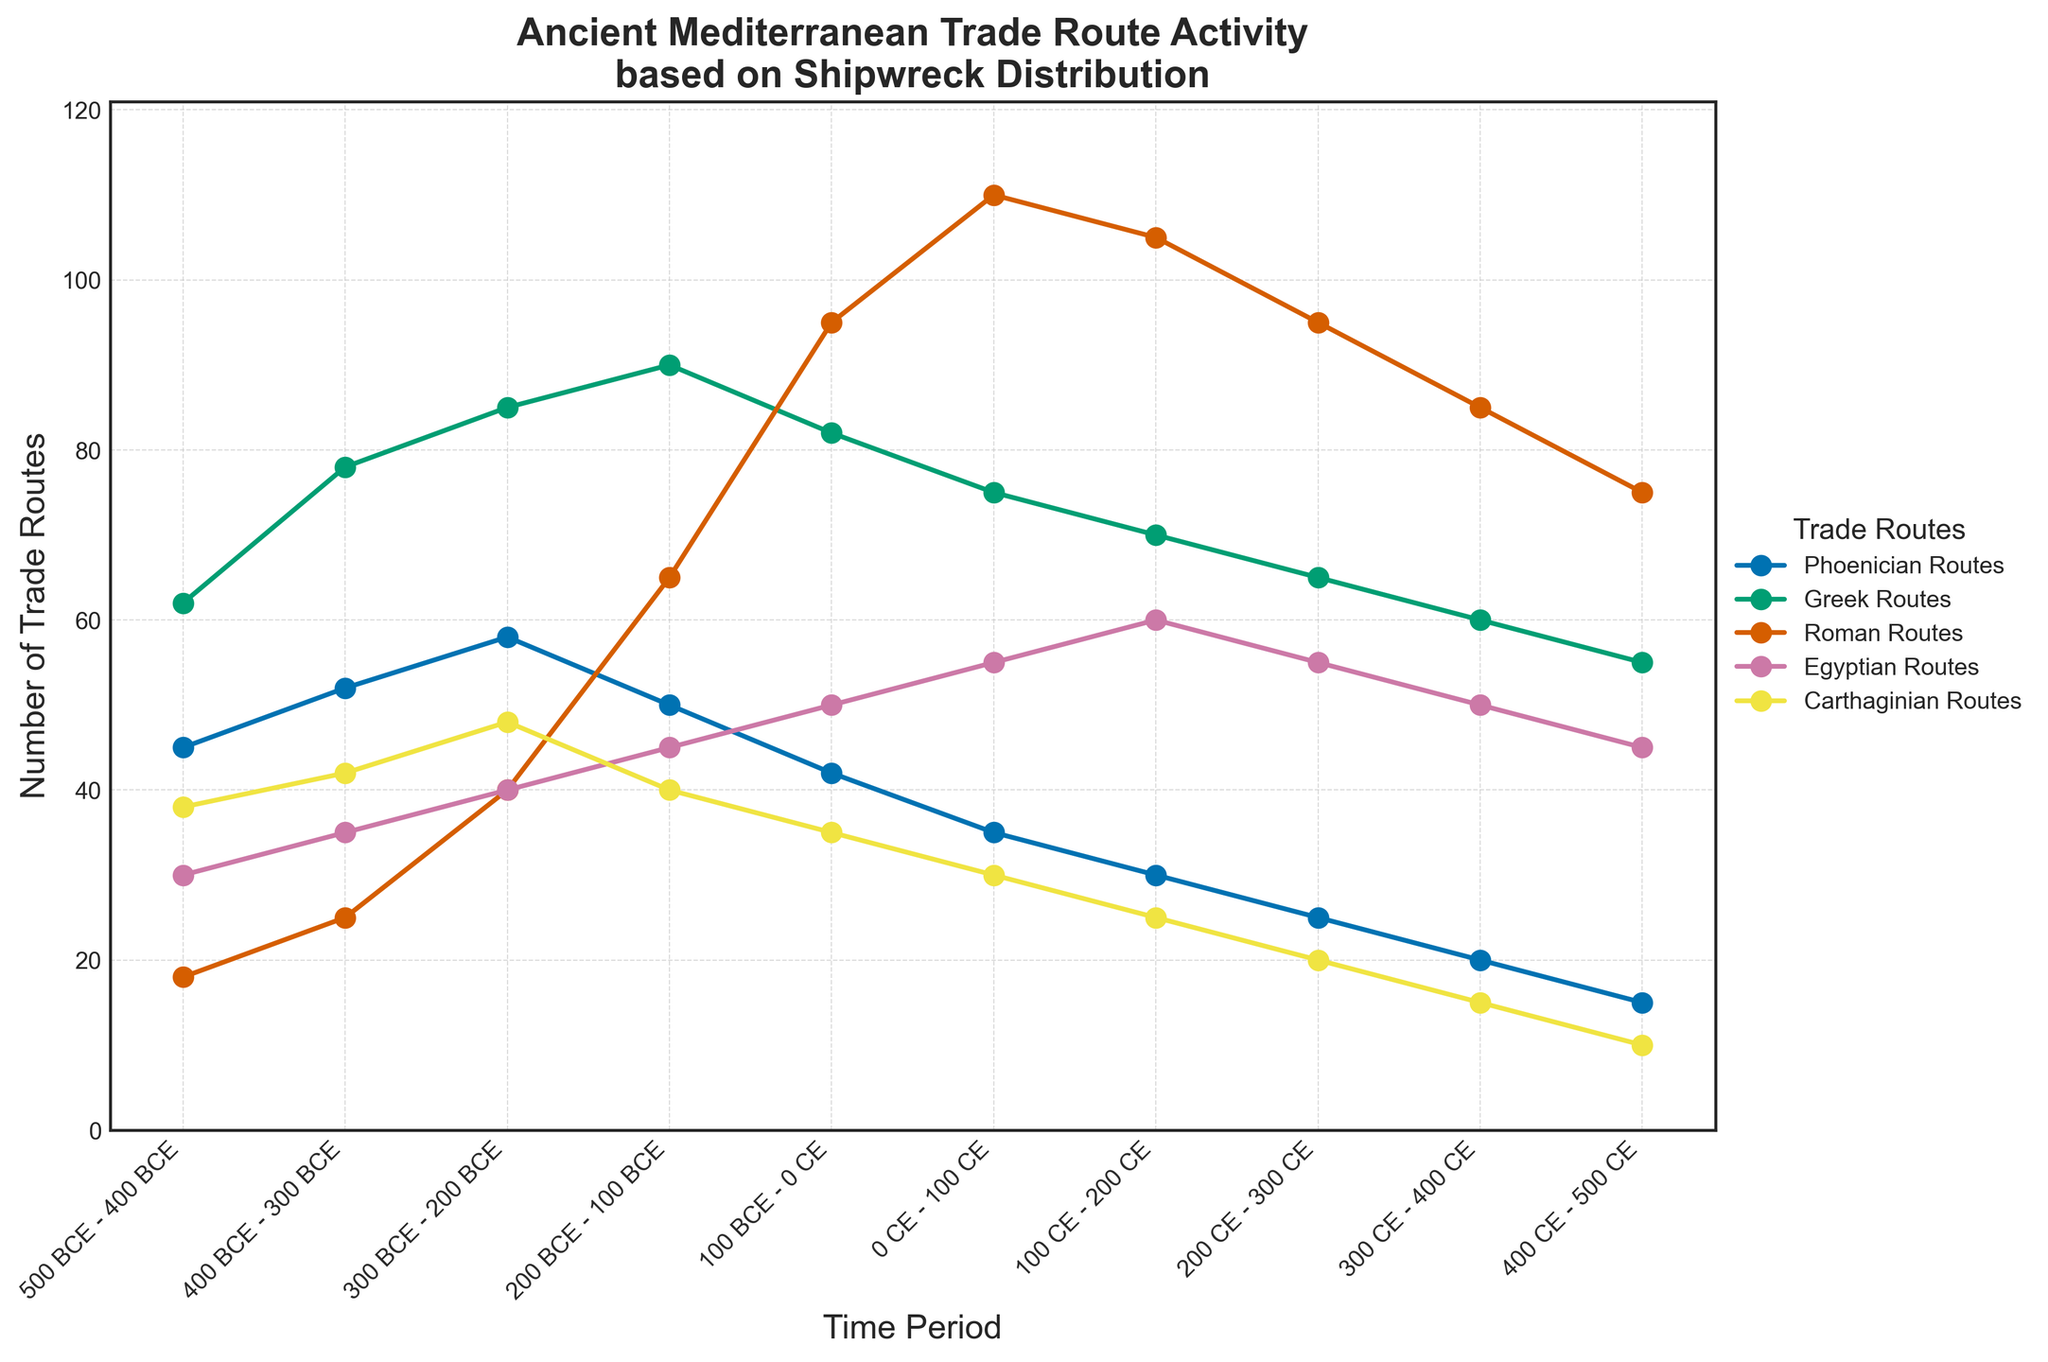What's the approximate difference in the number of Roman Routes between 0 CE - 100 CE and 400 CE - 500 CE? First, identify the number of Roman Routes in 0 CE - 100 CE, which is 110. Then, find the number of Roman Routes in 400 CE - 500 CE, which is 75. Subtract the latter from the former: 110 - 75 = 35
Answer: 35 During which time period did the Phoenician Routes peak? To find when the Phoenician Routes were highest, identify the highest value in the data. The peak value for Phoenician Routes is 58 during the period 300 BCE - 200 BCE.
Answer: 300 BCE - 200 BCE Comparing Egyptian Routes, where do we see the maximum activity and how many routes are recorded? Look at the Egyptian Routes values across all time periods. The maximum activity occurs in the period 100 CE - 200 CE with 60 routes.
Answer: 100 CE - 200 CE, 60 routes What trend do you observe in the number of Carthaginian Routes over time? Assess the numbers of Carthaginian Routes across each time period. The number generally decreases from 38 routes in 500 BCE - 400 BCE to 10 routes in 400 CE - 500 CE.
Answer: Decreasing trend Between which two consecutive time periods did the Greek Routes experience the largest increase? Compare the Greek Routes values between each consecutive time period to spot the largest difference. Notice the jump from 25 in 400 BCE - 300 BCE to 40 in 300 BCE - 200 BCE, an increase of 37 routes.
Answer: 400 BCE - 300 BCE to 300 BCE - 200 BCE Which two trade routes show a similar declining trend from 0 CE to 500 CE, and what are those trends? Observe trends for all routes starting from 0 CE. Both Phoenician and Carthaginian Routes show a similar declining trend: Phoenician Routes decline from 35 to 15, and Carthaginian Routes from 30 to 10.
Answer: Phoenician and Carthaginian Routes, declining trends During which time period is the gap between Greek Routes and Egyptian Routes the highest? Calculate the difference between Greek and Egyptian Routes for each period, identify the maximum gap. The greatest difference occurs in 0 CE - 100 CE with Greek Routes at 75 and Egyptian Routes at 55, difference is 20.
Answer: 0 CE - 100 CE Which trade route saw a peak within the time period 100 BCE - 200 CE, and what was the peak value? Check the data for all given routes within the period of 100 BCE - 200 CE. Roman Routes peaked with a value of 110 in 0 CE - 100 CE.
Answer: Roman Routes, 110 How do Phoenician Routes compare to Carthaginian Routes in 200 BCE - 100 BCE and what is the difference? Look at the values for both routes in the specified time. Phoenician Routes are 50, and Carthaginian Routes are 40. The difference is 50 - 40 = 10
Answer: 10 How does the number of Roman Routes from 100 BCE - 0 CE compare to Greek Routes in the same period? Identify the given values. Roman Routes count is 95 and Greek Routes count is 82. Romans exceed Greeks by 95 - 82 = 13
Answer: Roman Routes exceed by 13 